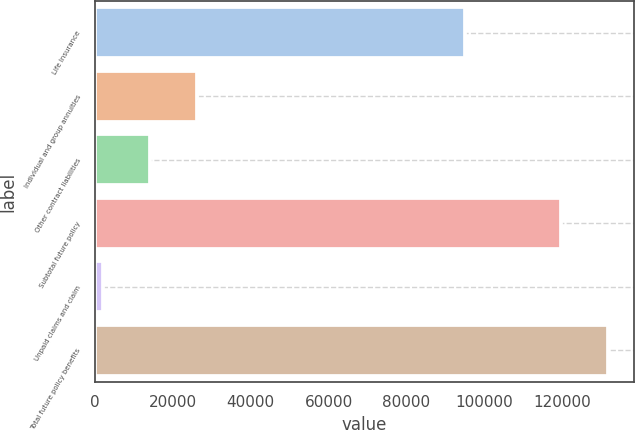<chart> <loc_0><loc_0><loc_500><loc_500><bar_chart><fcel>Life Insurance<fcel>Individual and group annuities<fcel>Other contract liabilities<fcel>Subtotal future policy<fcel>Unpaid claims and claim<fcel>Total future policy benefits<nl><fcel>94940<fcel>26115<fcel>14135.5<fcel>119795<fcel>2156<fcel>131774<nl></chart> 